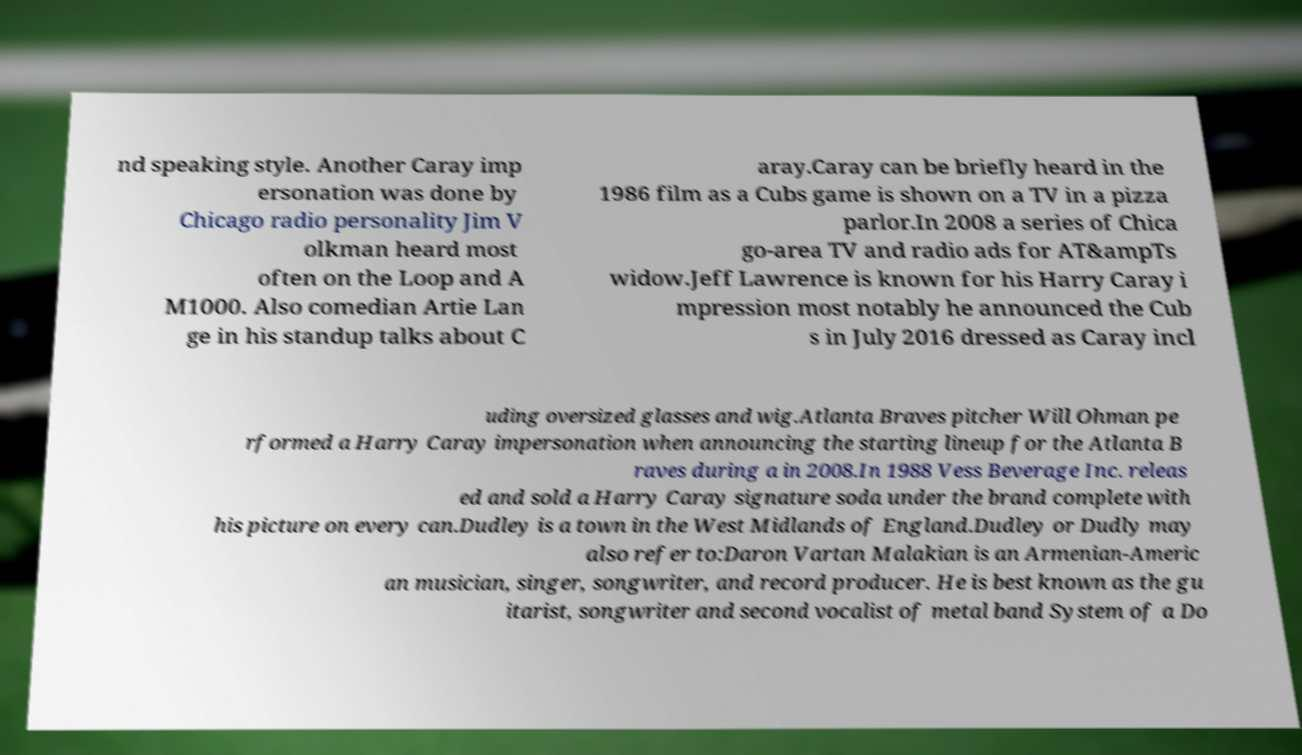Please identify and transcribe the text found in this image. nd speaking style. Another Caray imp ersonation was done by Chicago radio personality Jim V olkman heard most often on the Loop and A M1000. Also comedian Artie Lan ge in his standup talks about C aray.Caray can be briefly heard in the 1986 film as a Cubs game is shown on a TV in a pizza parlor.In 2008 a series of Chica go-area TV and radio ads for AT&ampTs widow.Jeff Lawrence is known for his Harry Caray i mpression most notably he announced the Cub s in July 2016 dressed as Caray incl uding oversized glasses and wig.Atlanta Braves pitcher Will Ohman pe rformed a Harry Caray impersonation when announcing the starting lineup for the Atlanta B raves during a in 2008.In 1988 Vess Beverage Inc. releas ed and sold a Harry Caray signature soda under the brand complete with his picture on every can.Dudley is a town in the West Midlands of England.Dudley or Dudly may also refer to:Daron Vartan Malakian is an Armenian-Americ an musician, singer, songwriter, and record producer. He is best known as the gu itarist, songwriter and second vocalist of metal band System of a Do 